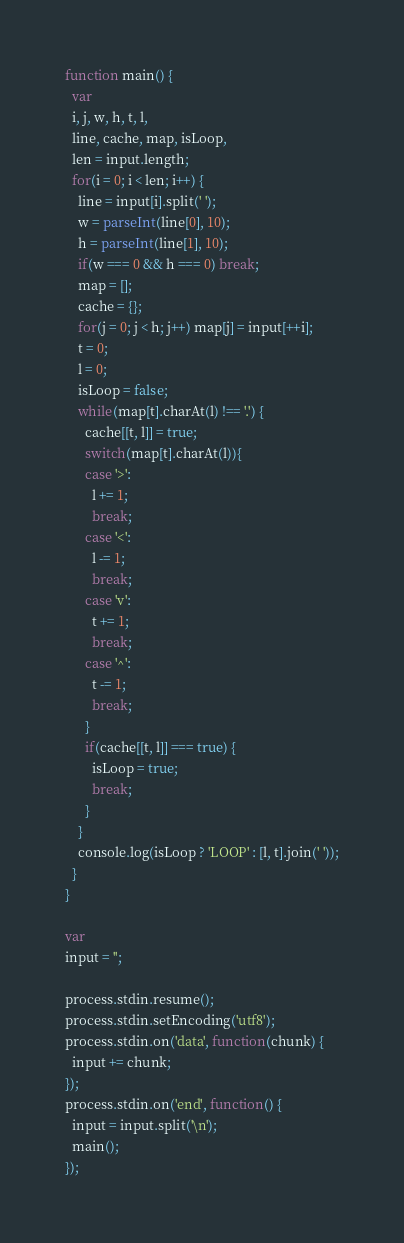Convert code to text. <code><loc_0><loc_0><loc_500><loc_500><_JavaScript_>function main() {
  var
  i, j, w, h, t, l,
  line, cache, map, isLoop,
  len = input.length;
  for(i = 0; i < len; i++) {
    line = input[i].split(' ');
    w = parseInt(line[0], 10);
    h = parseInt(line[1], 10);
    if(w === 0 && h === 0) break;
    map = [];
    cache = {};
    for(j = 0; j < h; j++) map[j] = input[++i];
    t = 0;
    l = 0;
    isLoop = false;
    while(map[t].charAt(l) !== '.') {
      cache[[t, l]] = true;
      switch(map[t].charAt(l)){
      case '>':
        l += 1;
        break;
      case '<':
        l -= 1;
        break;
      case 'v':
        t += 1;
        break;
      case '^':
        t -= 1;
        break;
      }
      if(cache[[t, l]] === true) {
        isLoop = true;
        break;
      }
    }
    console.log(isLoop ? 'LOOP' : [l, t].join(' '));
  }
}

var
input = '';

process.stdin.resume();
process.stdin.setEncoding('utf8');
process.stdin.on('data', function(chunk) {
  input += chunk;
});
process.stdin.on('end', function() {
  input = input.split('\n');
  main();
});</code> 